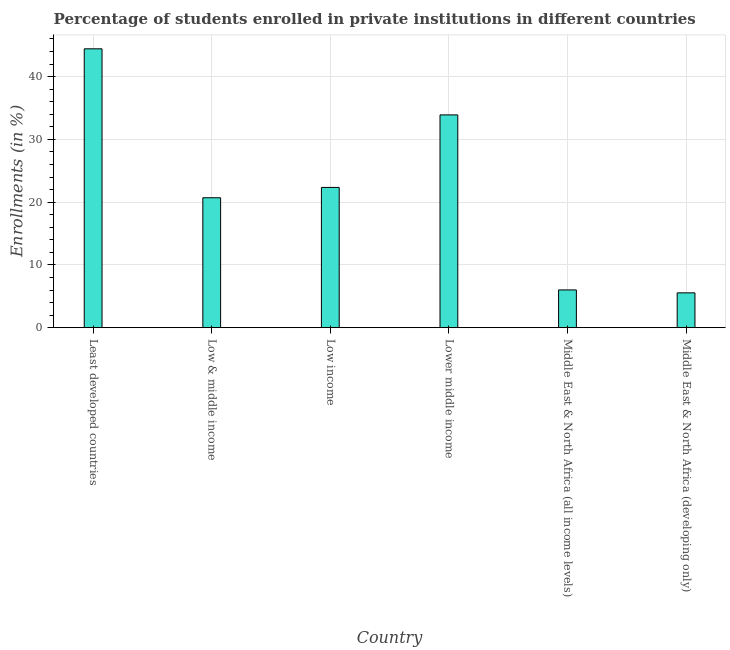Does the graph contain any zero values?
Ensure brevity in your answer.  No. Does the graph contain grids?
Your answer should be compact. Yes. What is the title of the graph?
Keep it short and to the point. Percentage of students enrolled in private institutions in different countries. What is the label or title of the X-axis?
Offer a very short reply. Country. What is the label or title of the Y-axis?
Offer a very short reply. Enrollments (in %). What is the enrollments in private institutions in Middle East & North Africa (developing only)?
Make the answer very short. 5.55. Across all countries, what is the maximum enrollments in private institutions?
Provide a succinct answer. 44.42. Across all countries, what is the minimum enrollments in private institutions?
Give a very brief answer. 5.55. In which country was the enrollments in private institutions maximum?
Your response must be concise. Least developed countries. In which country was the enrollments in private institutions minimum?
Provide a succinct answer. Middle East & North Africa (developing only). What is the sum of the enrollments in private institutions?
Your answer should be compact. 132.91. What is the difference between the enrollments in private institutions in Low & middle income and Lower middle income?
Make the answer very short. -13.2. What is the average enrollments in private institutions per country?
Your response must be concise. 22.15. What is the median enrollments in private institutions?
Keep it short and to the point. 21.52. In how many countries, is the enrollments in private institutions greater than 32 %?
Provide a short and direct response. 2. What is the ratio of the enrollments in private institutions in Low & middle income to that in Middle East & North Africa (developing only)?
Make the answer very short. 3.73. Is the enrollments in private institutions in Least developed countries less than that in Middle East & North Africa (all income levels)?
Make the answer very short. No. What is the difference between the highest and the second highest enrollments in private institutions?
Make the answer very short. 10.53. What is the difference between the highest and the lowest enrollments in private institutions?
Provide a short and direct response. 38.88. How many countries are there in the graph?
Make the answer very short. 6. What is the difference between two consecutive major ticks on the Y-axis?
Your answer should be compact. 10. What is the Enrollments (in %) in Least developed countries?
Give a very brief answer. 44.42. What is the Enrollments (in %) in Low & middle income?
Your response must be concise. 20.7. What is the Enrollments (in %) of Low income?
Ensure brevity in your answer.  22.34. What is the Enrollments (in %) of Lower middle income?
Make the answer very short. 33.89. What is the Enrollments (in %) in Middle East & North Africa (all income levels)?
Make the answer very short. 6.01. What is the Enrollments (in %) in Middle East & North Africa (developing only)?
Give a very brief answer. 5.55. What is the difference between the Enrollments (in %) in Least developed countries and Low & middle income?
Provide a short and direct response. 23.73. What is the difference between the Enrollments (in %) in Least developed countries and Low income?
Your answer should be very brief. 22.08. What is the difference between the Enrollments (in %) in Least developed countries and Lower middle income?
Make the answer very short. 10.53. What is the difference between the Enrollments (in %) in Least developed countries and Middle East & North Africa (all income levels)?
Offer a terse response. 38.41. What is the difference between the Enrollments (in %) in Least developed countries and Middle East & North Africa (developing only)?
Ensure brevity in your answer.  38.88. What is the difference between the Enrollments (in %) in Low & middle income and Low income?
Ensure brevity in your answer.  -1.64. What is the difference between the Enrollments (in %) in Low & middle income and Lower middle income?
Your response must be concise. -13.2. What is the difference between the Enrollments (in %) in Low & middle income and Middle East & North Africa (all income levels)?
Provide a succinct answer. 14.69. What is the difference between the Enrollments (in %) in Low & middle income and Middle East & North Africa (developing only)?
Give a very brief answer. 15.15. What is the difference between the Enrollments (in %) in Low income and Lower middle income?
Give a very brief answer. -11.55. What is the difference between the Enrollments (in %) in Low income and Middle East & North Africa (all income levels)?
Provide a short and direct response. 16.33. What is the difference between the Enrollments (in %) in Low income and Middle East & North Africa (developing only)?
Provide a succinct answer. 16.79. What is the difference between the Enrollments (in %) in Lower middle income and Middle East & North Africa (all income levels)?
Give a very brief answer. 27.88. What is the difference between the Enrollments (in %) in Lower middle income and Middle East & North Africa (developing only)?
Your response must be concise. 28.35. What is the difference between the Enrollments (in %) in Middle East & North Africa (all income levels) and Middle East & North Africa (developing only)?
Your answer should be very brief. 0.47. What is the ratio of the Enrollments (in %) in Least developed countries to that in Low & middle income?
Keep it short and to the point. 2.15. What is the ratio of the Enrollments (in %) in Least developed countries to that in Low income?
Provide a succinct answer. 1.99. What is the ratio of the Enrollments (in %) in Least developed countries to that in Lower middle income?
Offer a terse response. 1.31. What is the ratio of the Enrollments (in %) in Least developed countries to that in Middle East & North Africa (all income levels)?
Your answer should be very brief. 7.39. What is the ratio of the Enrollments (in %) in Least developed countries to that in Middle East & North Africa (developing only)?
Ensure brevity in your answer.  8.01. What is the ratio of the Enrollments (in %) in Low & middle income to that in Low income?
Provide a succinct answer. 0.93. What is the ratio of the Enrollments (in %) in Low & middle income to that in Lower middle income?
Offer a very short reply. 0.61. What is the ratio of the Enrollments (in %) in Low & middle income to that in Middle East & North Africa (all income levels)?
Offer a terse response. 3.44. What is the ratio of the Enrollments (in %) in Low & middle income to that in Middle East & North Africa (developing only)?
Offer a terse response. 3.73. What is the ratio of the Enrollments (in %) in Low income to that in Lower middle income?
Offer a very short reply. 0.66. What is the ratio of the Enrollments (in %) in Low income to that in Middle East & North Africa (all income levels)?
Provide a short and direct response. 3.72. What is the ratio of the Enrollments (in %) in Low income to that in Middle East & North Africa (developing only)?
Offer a terse response. 4.03. What is the ratio of the Enrollments (in %) in Lower middle income to that in Middle East & North Africa (all income levels)?
Offer a terse response. 5.64. What is the ratio of the Enrollments (in %) in Lower middle income to that in Middle East & North Africa (developing only)?
Ensure brevity in your answer.  6.11. What is the ratio of the Enrollments (in %) in Middle East & North Africa (all income levels) to that in Middle East & North Africa (developing only)?
Provide a short and direct response. 1.08. 